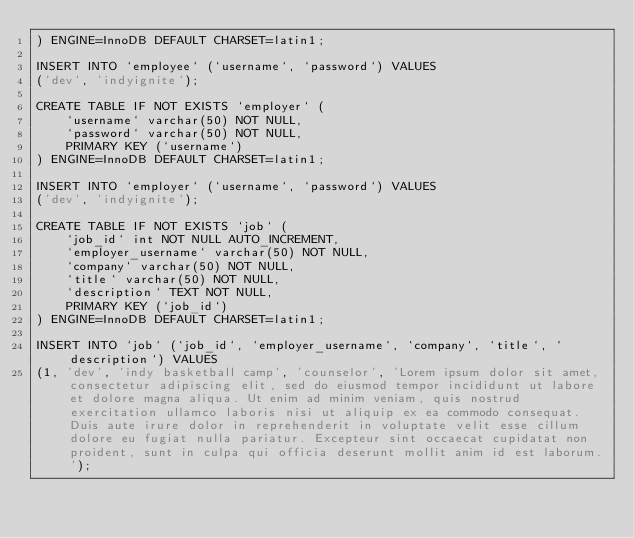<code> <loc_0><loc_0><loc_500><loc_500><_SQL_>) ENGINE=InnoDB DEFAULT CHARSET=latin1;

INSERT INTO `employee` (`username`, `password`) VALUES
('dev', 'indyignite');

CREATE TABLE IF NOT EXISTS `employer` (
    `username` varchar(50) NOT NULL,
    `password` varchar(50) NOT NULL,
    PRIMARY KEY (`username`)
) ENGINE=InnoDB DEFAULT CHARSET=latin1;

INSERT INTO `employer` (`username`, `password`) VALUES
('dev', 'indyignite');

CREATE TABLE IF NOT EXISTS `job` (
    `job_id` int NOT NULL AUTO_INCREMENT,
    `employer_username` varchar(50) NOT NULL,
    `company` varchar(50) NOT NULL,
    `title` varchar(50) NOT NULL,
    `description` TEXT NOT NULL,
    PRIMARY KEY (`job_id`)
) ENGINE=InnoDB DEFAULT CHARSET=latin1;

INSERT INTO `job` (`job_id`, `employer_username`, `company`, `title`, `description`) VALUES
(1, 'dev', 'indy basketball camp', 'counselor', 'Lorem ipsum dolor sit amet, consectetur adipiscing elit, sed do eiusmod tempor incididunt ut labore et dolore magna aliqua. Ut enim ad minim veniam, quis nostrud exercitation ullamco laboris nisi ut aliquip ex ea commodo consequat. Duis aute irure dolor in reprehenderit in voluptate velit esse cillum dolore eu fugiat nulla pariatur. Excepteur sint occaecat cupidatat non proident, sunt in culpa qui officia deserunt mollit anim id est laborum.');

</code> 